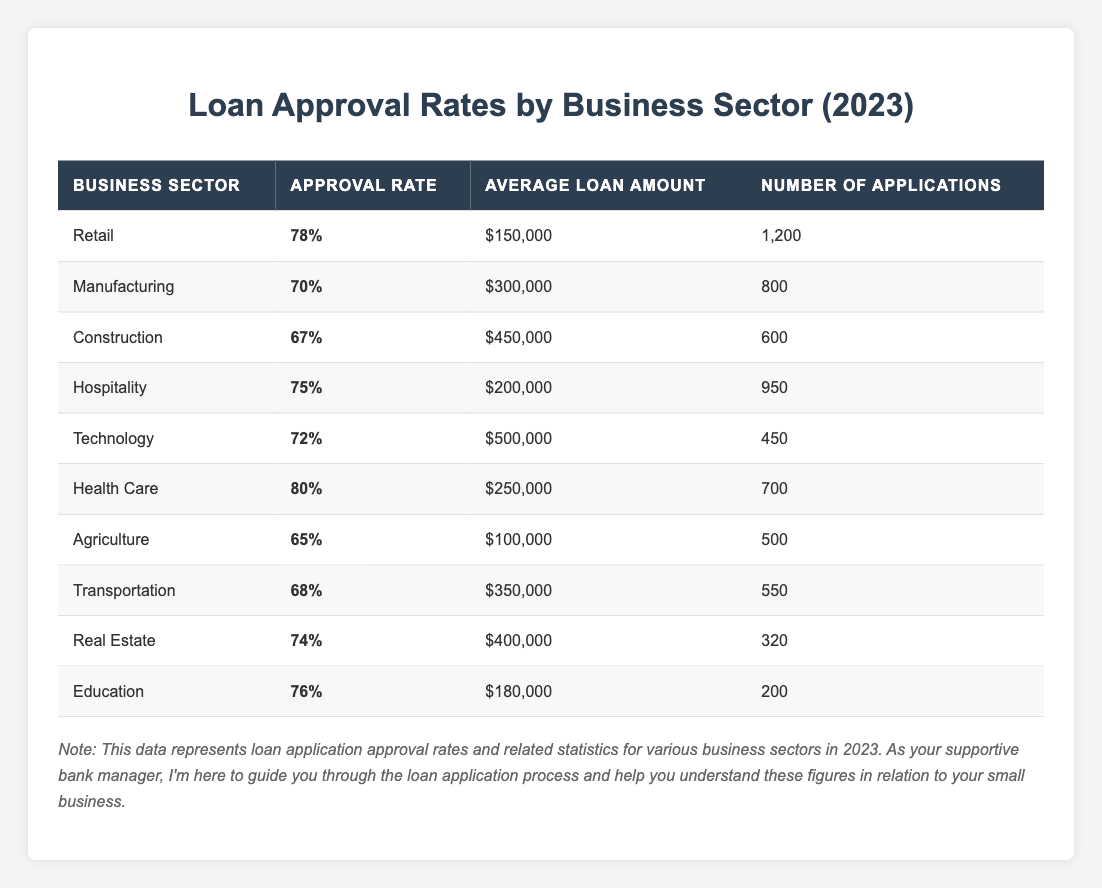What is the approval rate for the Health Care sector? The table shows that the approval rate for the Health Care sector is indicated next to its name, which is 80%.
Answer: 80% Which business sector has the lowest approval rate? By scanning the table, I can find that the Agriculture sector has the lowest approval rate at 65%.
Answer: Agriculture What is the average loan amount for the Manufacturing sector? The loan amount for Manufacturing is listed in the table as $300,000.
Answer: $300,000 How many applications were submitted in the Technology sector? The table clearly states that the number of applications for Technology is 450.
Answer: 450 What is the difference in approval rates between Retail and Hospitality sectors? The approval rate for Retail is 78%, while Hospitality is 75%. So, the difference is 78% - 75% = 3%.
Answer: 3% What is the average approval rate for all the sectors? To find the average, I sum up all the approval rates: (78 + 70 + 67 + 75 + 72 + 80 + 65 + 68 + 74 + 76) =  765. Then, divide by the number of sectors (10): 765 / 10 = 76.5%.
Answer: 76.5% Is the average loan amount for Health Care higher than for Agriculture? The average loan amount for Health Care is $250,000, and for Agriculture, it is $100,000. Since $250,000 is greater than $100,000, the statement is true.
Answer: Yes Which sector had more applications than the Construction sector? The Construction sector had 600 applications. Looking at the table, Retail (1200), Hospitality (950), and others had more than 600. Particularly, Retail and Hospitality exceed this number.
Answer: Retail and Hospitality What is the total number of applications submitted across all sectors? Adding up the number of applications from all sectors: (1200 + 800 + 600 + 950 + 450 + 700 + 500 + 550 + 320 + 200) gives a total of 5250 applications.
Answer: 5250 Which sector had the highest average loan amount? The table indicates that the Technology sector has the highest average loan amount at $500,000.
Answer: Technology Does the Real Estate sector have a better approval rate than the Transportation sector? The approval rate for Real Estate is 74% and for Transportation, it's 68%. Since 74% is greater than 68%, the statement is true.
Answer: Yes 